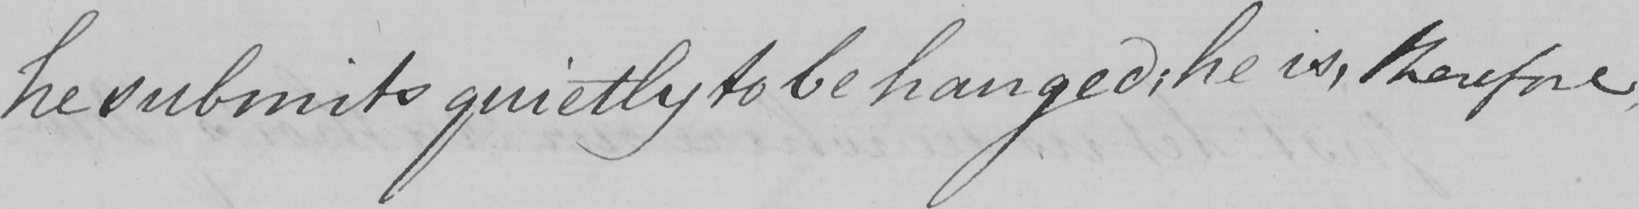Transcribe the text shown in this historical manuscript line. he submits quietly to be hanged :  he is , therefore 